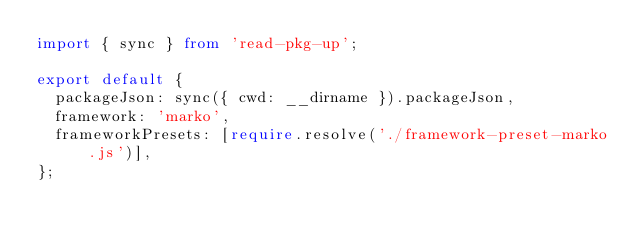Convert code to text. <code><loc_0><loc_0><loc_500><loc_500><_TypeScript_>import { sync } from 'read-pkg-up';

export default {
  packageJson: sync({ cwd: __dirname }).packageJson,
  framework: 'marko',
  frameworkPresets: [require.resolve('./framework-preset-marko.js')],
};
</code> 